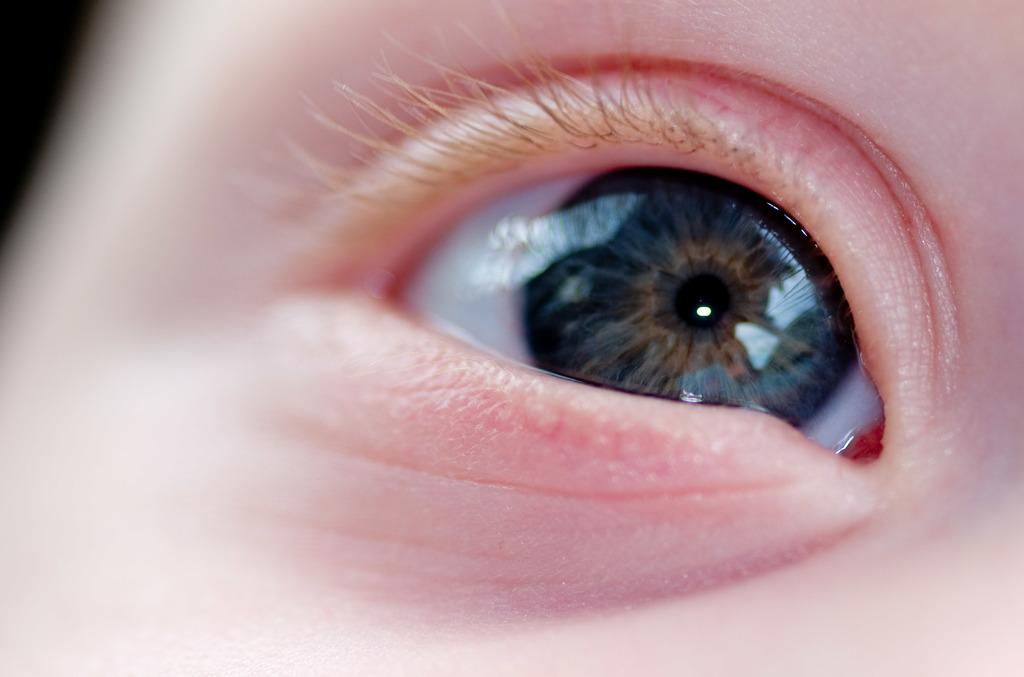What is the main subject of the image? The main subject of the image is a person's eye. What color is the iris of the eye in the image? The eyeball is black. What type of cork can be seen in the image? There is no cork present in the image; it features a person's eye. What event is taking place in the image? The image does not depict an event; it is a close-up of a person's eye. 